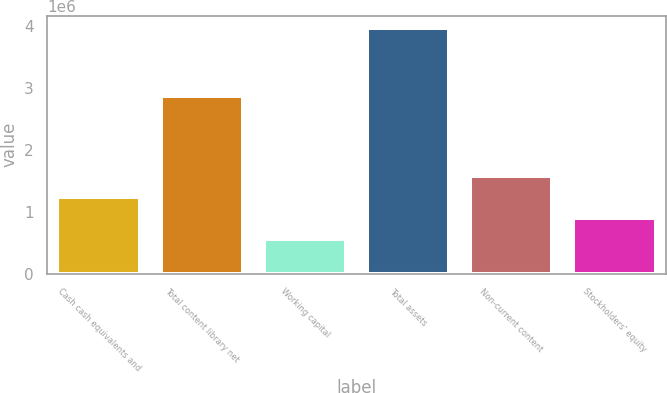<chart> <loc_0><loc_0><loc_500><loc_500><bar_chart><fcel>Cash cash equivalents and<fcel>Total content library net<fcel>Working capital<fcel>Total assets<fcel>Non-current content<fcel>Stockholders' equity<nl><fcel>1.24547e+06<fcel>2.87417e+06<fcel>564865<fcel>3.96789e+06<fcel>1.58577e+06<fcel>905168<nl></chart> 